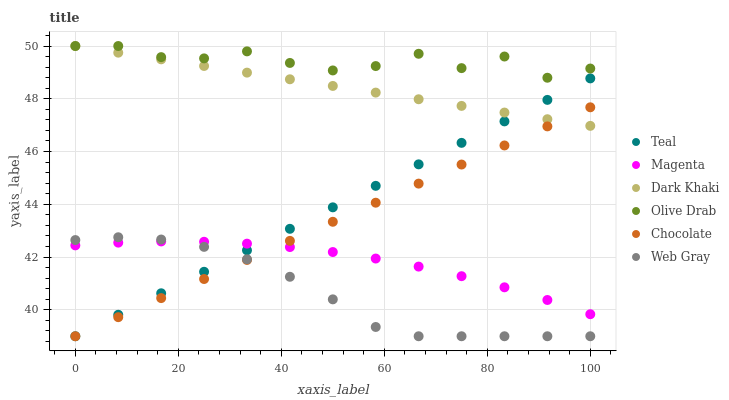Does Web Gray have the minimum area under the curve?
Answer yes or no. Yes. Does Olive Drab have the maximum area under the curve?
Answer yes or no. Yes. Does Chocolate have the minimum area under the curve?
Answer yes or no. No. Does Chocolate have the maximum area under the curve?
Answer yes or no. No. Is Dark Khaki the smoothest?
Answer yes or no. Yes. Is Olive Drab the roughest?
Answer yes or no. Yes. Is Chocolate the smoothest?
Answer yes or no. No. Is Chocolate the roughest?
Answer yes or no. No. Does Web Gray have the lowest value?
Answer yes or no. Yes. Does Dark Khaki have the lowest value?
Answer yes or no. No. Does Olive Drab have the highest value?
Answer yes or no. Yes. Does Chocolate have the highest value?
Answer yes or no. No. Is Web Gray less than Dark Khaki?
Answer yes or no. Yes. Is Olive Drab greater than Web Gray?
Answer yes or no. Yes. Does Chocolate intersect Magenta?
Answer yes or no. Yes. Is Chocolate less than Magenta?
Answer yes or no. No. Is Chocolate greater than Magenta?
Answer yes or no. No. Does Web Gray intersect Dark Khaki?
Answer yes or no. No. 